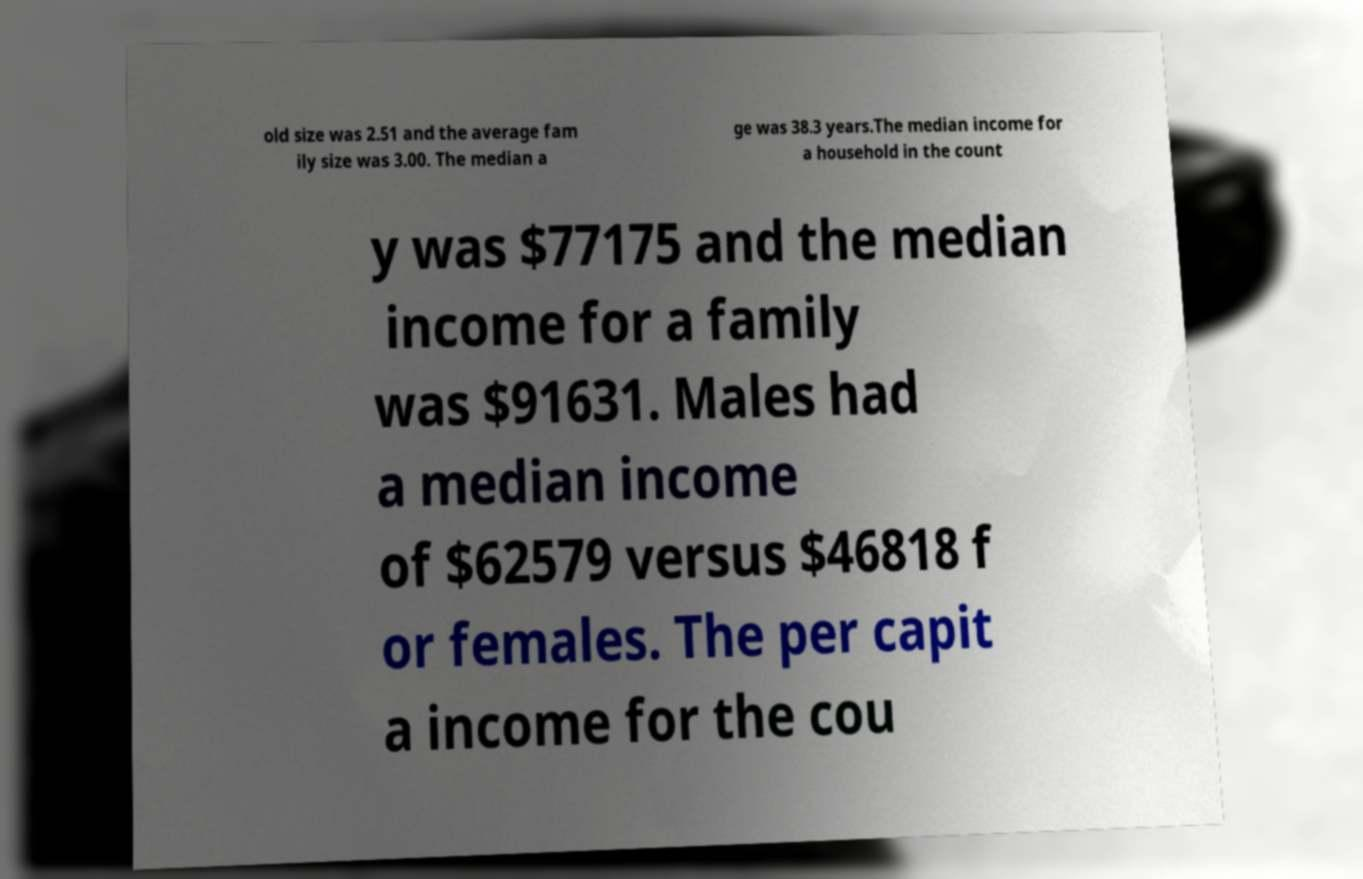What messages or text are displayed in this image? I need them in a readable, typed format. old size was 2.51 and the average fam ily size was 3.00. The median a ge was 38.3 years.The median income for a household in the count y was $77175 and the median income for a family was $91631. Males had a median income of $62579 versus $46818 f or females. The per capit a income for the cou 